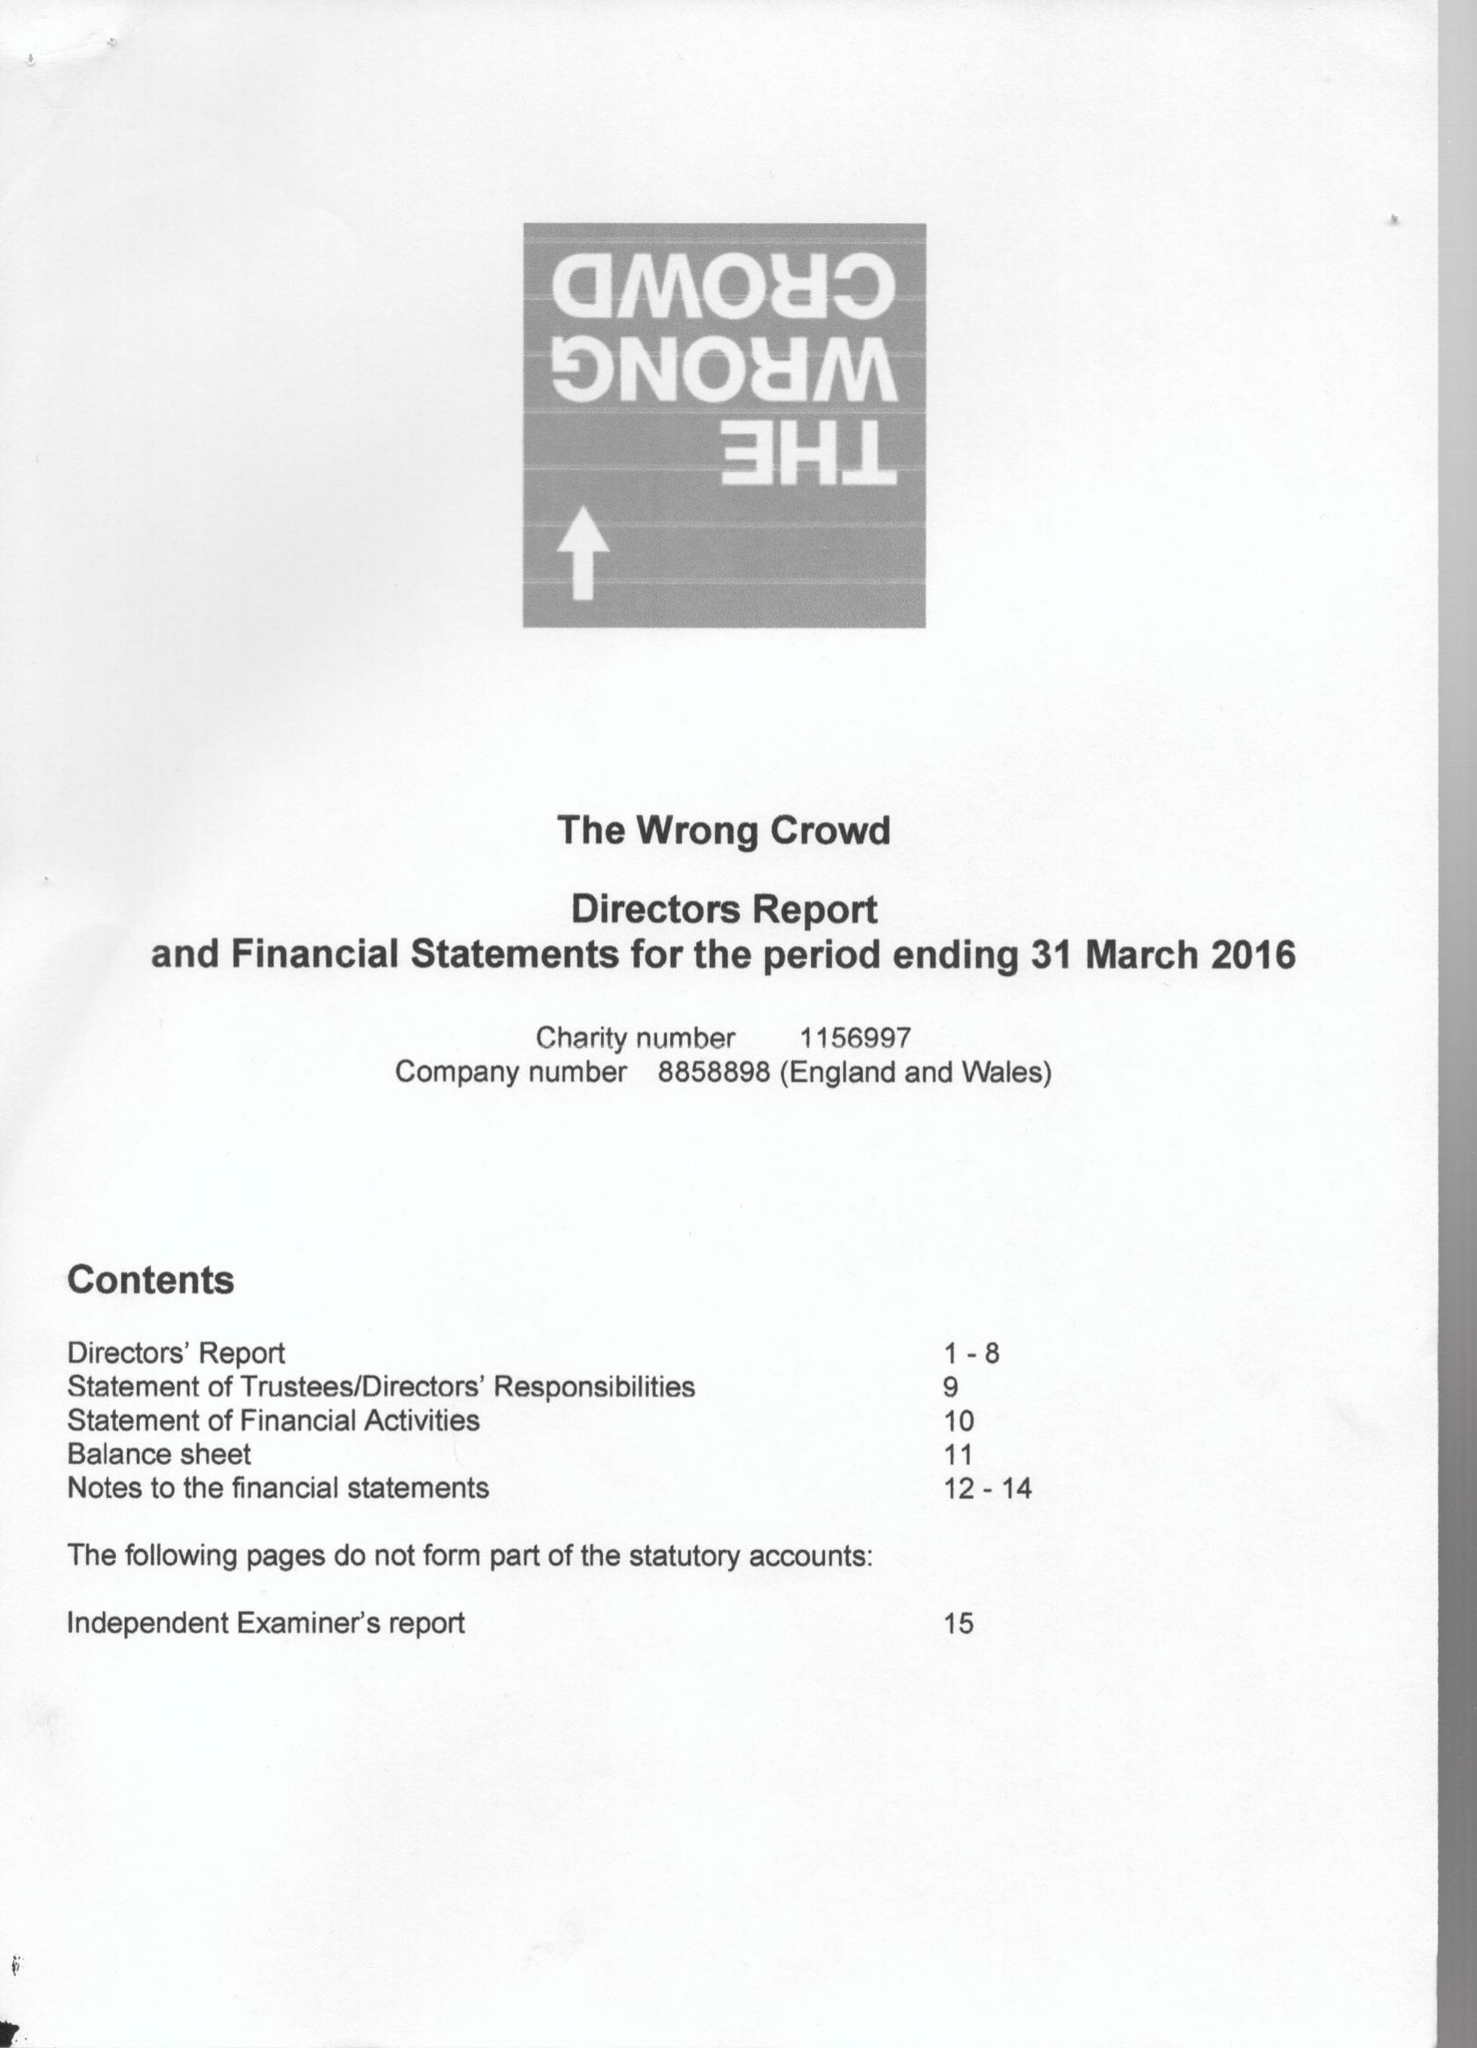What is the value for the address__postcode?
Answer the question using a single word or phrase. TQ9 6JG 